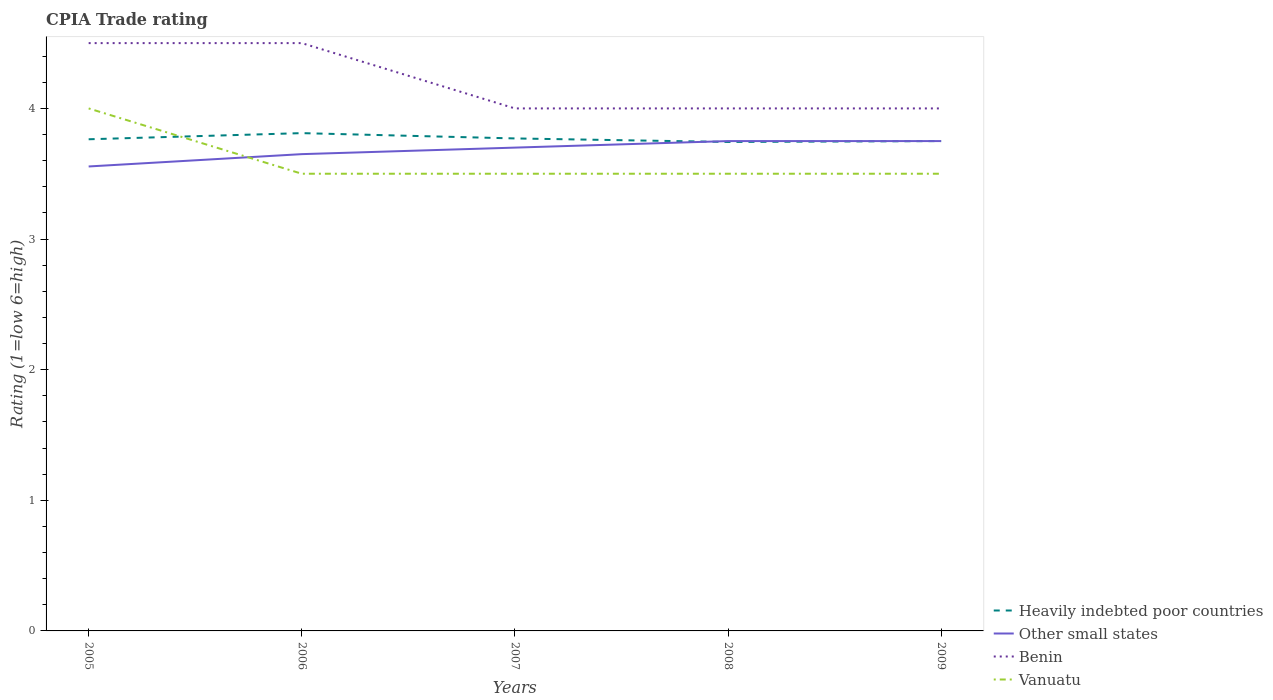Is the number of lines equal to the number of legend labels?
Keep it short and to the point. Yes. Across all years, what is the maximum CPIA rating in Other small states?
Ensure brevity in your answer.  3.56. What is the difference between the highest and the second highest CPIA rating in Heavily indebted poor countries?
Provide a succinct answer. 0.07. How many years are there in the graph?
Ensure brevity in your answer.  5. Does the graph contain any zero values?
Your response must be concise. No. Does the graph contain grids?
Offer a terse response. No. How many legend labels are there?
Offer a terse response. 4. What is the title of the graph?
Your response must be concise. CPIA Trade rating. What is the label or title of the X-axis?
Offer a very short reply. Years. What is the Rating (1=low 6=high) of Heavily indebted poor countries in 2005?
Keep it short and to the point. 3.76. What is the Rating (1=low 6=high) in Other small states in 2005?
Keep it short and to the point. 3.56. What is the Rating (1=low 6=high) of Benin in 2005?
Give a very brief answer. 4.5. What is the Rating (1=low 6=high) in Vanuatu in 2005?
Provide a succinct answer. 4. What is the Rating (1=low 6=high) in Heavily indebted poor countries in 2006?
Give a very brief answer. 3.81. What is the Rating (1=low 6=high) in Other small states in 2006?
Your answer should be very brief. 3.65. What is the Rating (1=low 6=high) in Benin in 2006?
Your response must be concise. 4.5. What is the Rating (1=low 6=high) in Heavily indebted poor countries in 2007?
Provide a short and direct response. 3.77. What is the Rating (1=low 6=high) in Heavily indebted poor countries in 2008?
Give a very brief answer. 3.74. What is the Rating (1=low 6=high) in Other small states in 2008?
Your response must be concise. 3.75. What is the Rating (1=low 6=high) in Benin in 2008?
Make the answer very short. 4. What is the Rating (1=low 6=high) of Vanuatu in 2008?
Ensure brevity in your answer.  3.5. What is the Rating (1=low 6=high) in Heavily indebted poor countries in 2009?
Keep it short and to the point. 3.75. What is the Rating (1=low 6=high) of Other small states in 2009?
Your answer should be compact. 3.75. What is the Rating (1=low 6=high) of Vanuatu in 2009?
Give a very brief answer. 3.5. Across all years, what is the maximum Rating (1=low 6=high) of Heavily indebted poor countries?
Offer a terse response. 3.81. Across all years, what is the maximum Rating (1=low 6=high) in Other small states?
Give a very brief answer. 3.75. Across all years, what is the maximum Rating (1=low 6=high) of Benin?
Provide a succinct answer. 4.5. Across all years, what is the maximum Rating (1=low 6=high) in Vanuatu?
Offer a very short reply. 4. Across all years, what is the minimum Rating (1=low 6=high) of Heavily indebted poor countries?
Ensure brevity in your answer.  3.74. Across all years, what is the minimum Rating (1=low 6=high) of Other small states?
Your answer should be compact. 3.56. Across all years, what is the minimum Rating (1=low 6=high) in Vanuatu?
Make the answer very short. 3.5. What is the total Rating (1=low 6=high) of Heavily indebted poor countries in the graph?
Give a very brief answer. 18.84. What is the total Rating (1=low 6=high) of Other small states in the graph?
Make the answer very short. 18.41. What is the total Rating (1=low 6=high) in Vanuatu in the graph?
Your answer should be very brief. 18. What is the difference between the Rating (1=low 6=high) of Heavily indebted poor countries in 2005 and that in 2006?
Give a very brief answer. -0.05. What is the difference between the Rating (1=low 6=high) in Other small states in 2005 and that in 2006?
Your answer should be very brief. -0.09. What is the difference between the Rating (1=low 6=high) of Vanuatu in 2005 and that in 2006?
Ensure brevity in your answer.  0.5. What is the difference between the Rating (1=low 6=high) of Heavily indebted poor countries in 2005 and that in 2007?
Give a very brief answer. -0.01. What is the difference between the Rating (1=low 6=high) of Other small states in 2005 and that in 2007?
Provide a short and direct response. -0.14. What is the difference between the Rating (1=low 6=high) in Benin in 2005 and that in 2007?
Provide a short and direct response. 0.5. What is the difference between the Rating (1=low 6=high) of Heavily indebted poor countries in 2005 and that in 2008?
Keep it short and to the point. 0.02. What is the difference between the Rating (1=low 6=high) of Other small states in 2005 and that in 2008?
Give a very brief answer. -0.19. What is the difference between the Rating (1=low 6=high) in Heavily indebted poor countries in 2005 and that in 2009?
Your answer should be very brief. 0.01. What is the difference between the Rating (1=low 6=high) in Other small states in 2005 and that in 2009?
Offer a very short reply. -0.19. What is the difference between the Rating (1=low 6=high) of Vanuatu in 2005 and that in 2009?
Your response must be concise. 0.5. What is the difference between the Rating (1=low 6=high) in Heavily indebted poor countries in 2006 and that in 2007?
Give a very brief answer. 0.04. What is the difference between the Rating (1=low 6=high) in Other small states in 2006 and that in 2007?
Give a very brief answer. -0.05. What is the difference between the Rating (1=low 6=high) in Heavily indebted poor countries in 2006 and that in 2008?
Ensure brevity in your answer.  0.07. What is the difference between the Rating (1=low 6=high) of Heavily indebted poor countries in 2006 and that in 2009?
Offer a very short reply. 0.06. What is the difference between the Rating (1=low 6=high) of Benin in 2006 and that in 2009?
Keep it short and to the point. 0.5. What is the difference between the Rating (1=low 6=high) of Vanuatu in 2006 and that in 2009?
Provide a succinct answer. 0. What is the difference between the Rating (1=low 6=high) in Heavily indebted poor countries in 2007 and that in 2008?
Provide a succinct answer. 0.03. What is the difference between the Rating (1=low 6=high) in Other small states in 2007 and that in 2008?
Your answer should be very brief. -0.05. What is the difference between the Rating (1=low 6=high) of Benin in 2007 and that in 2008?
Give a very brief answer. 0. What is the difference between the Rating (1=low 6=high) of Heavily indebted poor countries in 2007 and that in 2009?
Offer a terse response. 0.02. What is the difference between the Rating (1=low 6=high) in Other small states in 2007 and that in 2009?
Provide a succinct answer. -0.05. What is the difference between the Rating (1=low 6=high) in Heavily indebted poor countries in 2008 and that in 2009?
Provide a succinct answer. -0.01. What is the difference between the Rating (1=low 6=high) of Benin in 2008 and that in 2009?
Ensure brevity in your answer.  0. What is the difference between the Rating (1=low 6=high) of Heavily indebted poor countries in 2005 and the Rating (1=low 6=high) of Other small states in 2006?
Give a very brief answer. 0.11. What is the difference between the Rating (1=low 6=high) in Heavily indebted poor countries in 2005 and the Rating (1=low 6=high) in Benin in 2006?
Your response must be concise. -0.74. What is the difference between the Rating (1=low 6=high) of Heavily indebted poor countries in 2005 and the Rating (1=low 6=high) of Vanuatu in 2006?
Your answer should be very brief. 0.26. What is the difference between the Rating (1=low 6=high) in Other small states in 2005 and the Rating (1=low 6=high) in Benin in 2006?
Make the answer very short. -0.94. What is the difference between the Rating (1=low 6=high) of Other small states in 2005 and the Rating (1=low 6=high) of Vanuatu in 2006?
Provide a short and direct response. 0.06. What is the difference between the Rating (1=low 6=high) in Benin in 2005 and the Rating (1=low 6=high) in Vanuatu in 2006?
Make the answer very short. 1. What is the difference between the Rating (1=low 6=high) in Heavily indebted poor countries in 2005 and the Rating (1=low 6=high) in Other small states in 2007?
Your response must be concise. 0.06. What is the difference between the Rating (1=low 6=high) in Heavily indebted poor countries in 2005 and the Rating (1=low 6=high) in Benin in 2007?
Keep it short and to the point. -0.24. What is the difference between the Rating (1=low 6=high) in Heavily indebted poor countries in 2005 and the Rating (1=low 6=high) in Vanuatu in 2007?
Give a very brief answer. 0.26. What is the difference between the Rating (1=low 6=high) in Other small states in 2005 and the Rating (1=low 6=high) in Benin in 2007?
Ensure brevity in your answer.  -0.44. What is the difference between the Rating (1=low 6=high) of Other small states in 2005 and the Rating (1=low 6=high) of Vanuatu in 2007?
Give a very brief answer. 0.06. What is the difference between the Rating (1=low 6=high) in Benin in 2005 and the Rating (1=low 6=high) in Vanuatu in 2007?
Offer a terse response. 1. What is the difference between the Rating (1=low 6=high) of Heavily indebted poor countries in 2005 and the Rating (1=low 6=high) of Other small states in 2008?
Offer a terse response. 0.01. What is the difference between the Rating (1=low 6=high) in Heavily indebted poor countries in 2005 and the Rating (1=low 6=high) in Benin in 2008?
Provide a succinct answer. -0.24. What is the difference between the Rating (1=low 6=high) of Heavily indebted poor countries in 2005 and the Rating (1=low 6=high) of Vanuatu in 2008?
Offer a very short reply. 0.26. What is the difference between the Rating (1=low 6=high) of Other small states in 2005 and the Rating (1=low 6=high) of Benin in 2008?
Offer a terse response. -0.44. What is the difference between the Rating (1=low 6=high) of Other small states in 2005 and the Rating (1=low 6=high) of Vanuatu in 2008?
Offer a very short reply. 0.06. What is the difference between the Rating (1=low 6=high) in Benin in 2005 and the Rating (1=low 6=high) in Vanuatu in 2008?
Your answer should be compact. 1. What is the difference between the Rating (1=low 6=high) of Heavily indebted poor countries in 2005 and the Rating (1=low 6=high) of Other small states in 2009?
Keep it short and to the point. 0.01. What is the difference between the Rating (1=low 6=high) of Heavily indebted poor countries in 2005 and the Rating (1=low 6=high) of Benin in 2009?
Provide a succinct answer. -0.24. What is the difference between the Rating (1=low 6=high) of Heavily indebted poor countries in 2005 and the Rating (1=low 6=high) of Vanuatu in 2009?
Provide a succinct answer. 0.26. What is the difference between the Rating (1=low 6=high) in Other small states in 2005 and the Rating (1=low 6=high) in Benin in 2009?
Offer a terse response. -0.44. What is the difference between the Rating (1=low 6=high) of Other small states in 2005 and the Rating (1=low 6=high) of Vanuatu in 2009?
Your answer should be very brief. 0.06. What is the difference between the Rating (1=low 6=high) in Benin in 2005 and the Rating (1=low 6=high) in Vanuatu in 2009?
Ensure brevity in your answer.  1. What is the difference between the Rating (1=low 6=high) in Heavily indebted poor countries in 2006 and the Rating (1=low 6=high) in Other small states in 2007?
Keep it short and to the point. 0.11. What is the difference between the Rating (1=low 6=high) in Heavily indebted poor countries in 2006 and the Rating (1=low 6=high) in Benin in 2007?
Your answer should be compact. -0.19. What is the difference between the Rating (1=low 6=high) of Heavily indebted poor countries in 2006 and the Rating (1=low 6=high) of Vanuatu in 2007?
Your answer should be very brief. 0.31. What is the difference between the Rating (1=low 6=high) in Other small states in 2006 and the Rating (1=low 6=high) in Benin in 2007?
Your response must be concise. -0.35. What is the difference between the Rating (1=low 6=high) of Heavily indebted poor countries in 2006 and the Rating (1=low 6=high) of Other small states in 2008?
Ensure brevity in your answer.  0.06. What is the difference between the Rating (1=low 6=high) in Heavily indebted poor countries in 2006 and the Rating (1=low 6=high) in Benin in 2008?
Keep it short and to the point. -0.19. What is the difference between the Rating (1=low 6=high) in Heavily indebted poor countries in 2006 and the Rating (1=low 6=high) in Vanuatu in 2008?
Offer a terse response. 0.31. What is the difference between the Rating (1=low 6=high) in Other small states in 2006 and the Rating (1=low 6=high) in Benin in 2008?
Make the answer very short. -0.35. What is the difference between the Rating (1=low 6=high) of Benin in 2006 and the Rating (1=low 6=high) of Vanuatu in 2008?
Offer a terse response. 1. What is the difference between the Rating (1=low 6=high) of Heavily indebted poor countries in 2006 and the Rating (1=low 6=high) of Other small states in 2009?
Make the answer very short. 0.06. What is the difference between the Rating (1=low 6=high) of Heavily indebted poor countries in 2006 and the Rating (1=low 6=high) of Benin in 2009?
Ensure brevity in your answer.  -0.19. What is the difference between the Rating (1=low 6=high) of Heavily indebted poor countries in 2006 and the Rating (1=low 6=high) of Vanuatu in 2009?
Your answer should be very brief. 0.31. What is the difference between the Rating (1=low 6=high) in Other small states in 2006 and the Rating (1=low 6=high) in Benin in 2009?
Your response must be concise. -0.35. What is the difference between the Rating (1=low 6=high) in Benin in 2006 and the Rating (1=low 6=high) in Vanuatu in 2009?
Make the answer very short. 1. What is the difference between the Rating (1=low 6=high) of Heavily indebted poor countries in 2007 and the Rating (1=low 6=high) of Other small states in 2008?
Offer a terse response. 0.02. What is the difference between the Rating (1=low 6=high) of Heavily indebted poor countries in 2007 and the Rating (1=low 6=high) of Benin in 2008?
Provide a short and direct response. -0.23. What is the difference between the Rating (1=low 6=high) of Heavily indebted poor countries in 2007 and the Rating (1=low 6=high) of Vanuatu in 2008?
Your answer should be very brief. 0.27. What is the difference between the Rating (1=low 6=high) of Other small states in 2007 and the Rating (1=low 6=high) of Vanuatu in 2008?
Make the answer very short. 0.2. What is the difference between the Rating (1=low 6=high) of Benin in 2007 and the Rating (1=low 6=high) of Vanuatu in 2008?
Offer a terse response. 0.5. What is the difference between the Rating (1=low 6=high) of Heavily indebted poor countries in 2007 and the Rating (1=low 6=high) of Other small states in 2009?
Your response must be concise. 0.02. What is the difference between the Rating (1=low 6=high) in Heavily indebted poor countries in 2007 and the Rating (1=low 6=high) in Benin in 2009?
Keep it short and to the point. -0.23. What is the difference between the Rating (1=low 6=high) of Heavily indebted poor countries in 2007 and the Rating (1=low 6=high) of Vanuatu in 2009?
Provide a short and direct response. 0.27. What is the difference between the Rating (1=low 6=high) of Other small states in 2007 and the Rating (1=low 6=high) of Vanuatu in 2009?
Offer a terse response. 0.2. What is the difference between the Rating (1=low 6=high) of Benin in 2007 and the Rating (1=low 6=high) of Vanuatu in 2009?
Offer a terse response. 0.5. What is the difference between the Rating (1=low 6=high) of Heavily indebted poor countries in 2008 and the Rating (1=low 6=high) of Other small states in 2009?
Give a very brief answer. -0.01. What is the difference between the Rating (1=low 6=high) in Heavily indebted poor countries in 2008 and the Rating (1=low 6=high) in Benin in 2009?
Your answer should be very brief. -0.26. What is the difference between the Rating (1=low 6=high) in Heavily indebted poor countries in 2008 and the Rating (1=low 6=high) in Vanuatu in 2009?
Your response must be concise. 0.24. What is the difference between the Rating (1=low 6=high) of Other small states in 2008 and the Rating (1=low 6=high) of Vanuatu in 2009?
Give a very brief answer. 0.25. What is the average Rating (1=low 6=high) of Heavily indebted poor countries per year?
Provide a short and direct response. 3.77. What is the average Rating (1=low 6=high) in Other small states per year?
Offer a terse response. 3.68. In the year 2005, what is the difference between the Rating (1=low 6=high) in Heavily indebted poor countries and Rating (1=low 6=high) in Other small states?
Offer a terse response. 0.21. In the year 2005, what is the difference between the Rating (1=low 6=high) in Heavily indebted poor countries and Rating (1=low 6=high) in Benin?
Make the answer very short. -0.74. In the year 2005, what is the difference between the Rating (1=low 6=high) in Heavily indebted poor countries and Rating (1=low 6=high) in Vanuatu?
Your answer should be very brief. -0.24. In the year 2005, what is the difference between the Rating (1=low 6=high) in Other small states and Rating (1=low 6=high) in Benin?
Keep it short and to the point. -0.94. In the year 2005, what is the difference between the Rating (1=low 6=high) in Other small states and Rating (1=low 6=high) in Vanuatu?
Your answer should be very brief. -0.44. In the year 2006, what is the difference between the Rating (1=low 6=high) of Heavily indebted poor countries and Rating (1=low 6=high) of Other small states?
Make the answer very short. 0.16. In the year 2006, what is the difference between the Rating (1=low 6=high) of Heavily indebted poor countries and Rating (1=low 6=high) of Benin?
Your response must be concise. -0.69. In the year 2006, what is the difference between the Rating (1=low 6=high) in Heavily indebted poor countries and Rating (1=low 6=high) in Vanuatu?
Your answer should be compact. 0.31. In the year 2006, what is the difference between the Rating (1=low 6=high) of Other small states and Rating (1=low 6=high) of Benin?
Offer a very short reply. -0.85. In the year 2006, what is the difference between the Rating (1=low 6=high) in Other small states and Rating (1=low 6=high) in Vanuatu?
Offer a terse response. 0.15. In the year 2006, what is the difference between the Rating (1=low 6=high) in Benin and Rating (1=low 6=high) in Vanuatu?
Offer a terse response. 1. In the year 2007, what is the difference between the Rating (1=low 6=high) of Heavily indebted poor countries and Rating (1=low 6=high) of Other small states?
Offer a terse response. 0.07. In the year 2007, what is the difference between the Rating (1=low 6=high) in Heavily indebted poor countries and Rating (1=low 6=high) in Benin?
Give a very brief answer. -0.23. In the year 2007, what is the difference between the Rating (1=low 6=high) in Heavily indebted poor countries and Rating (1=low 6=high) in Vanuatu?
Provide a short and direct response. 0.27. In the year 2007, what is the difference between the Rating (1=low 6=high) of Benin and Rating (1=low 6=high) of Vanuatu?
Give a very brief answer. 0.5. In the year 2008, what is the difference between the Rating (1=low 6=high) in Heavily indebted poor countries and Rating (1=low 6=high) in Other small states?
Give a very brief answer. -0.01. In the year 2008, what is the difference between the Rating (1=low 6=high) in Heavily indebted poor countries and Rating (1=low 6=high) in Benin?
Keep it short and to the point. -0.26. In the year 2008, what is the difference between the Rating (1=low 6=high) of Heavily indebted poor countries and Rating (1=low 6=high) of Vanuatu?
Ensure brevity in your answer.  0.24. In the year 2008, what is the difference between the Rating (1=low 6=high) of Other small states and Rating (1=low 6=high) of Vanuatu?
Give a very brief answer. 0.25. In the year 2009, what is the difference between the Rating (1=low 6=high) of Heavily indebted poor countries and Rating (1=low 6=high) of Vanuatu?
Your response must be concise. 0.25. In the year 2009, what is the difference between the Rating (1=low 6=high) of Other small states and Rating (1=low 6=high) of Benin?
Your answer should be very brief. -0.25. In the year 2009, what is the difference between the Rating (1=low 6=high) in Other small states and Rating (1=low 6=high) in Vanuatu?
Your response must be concise. 0.25. What is the ratio of the Rating (1=low 6=high) in Heavily indebted poor countries in 2005 to that in 2006?
Offer a terse response. 0.99. What is the ratio of the Rating (1=low 6=high) in Other small states in 2005 to that in 2006?
Make the answer very short. 0.97. What is the ratio of the Rating (1=low 6=high) of Benin in 2005 to that in 2006?
Ensure brevity in your answer.  1. What is the ratio of the Rating (1=low 6=high) of Heavily indebted poor countries in 2005 to that in 2007?
Your answer should be very brief. 1. What is the ratio of the Rating (1=low 6=high) of Vanuatu in 2005 to that in 2007?
Provide a short and direct response. 1.14. What is the ratio of the Rating (1=low 6=high) in Heavily indebted poor countries in 2005 to that in 2008?
Offer a terse response. 1.01. What is the ratio of the Rating (1=low 6=high) in Other small states in 2005 to that in 2008?
Make the answer very short. 0.95. What is the ratio of the Rating (1=low 6=high) in Heavily indebted poor countries in 2005 to that in 2009?
Give a very brief answer. 1. What is the ratio of the Rating (1=low 6=high) of Other small states in 2005 to that in 2009?
Offer a very short reply. 0.95. What is the ratio of the Rating (1=low 6=high) in Vanuatu in 2005 to that in 2009?
Make the answer very short. 1.14. What is the ratio of the Rating (1=low 6=high) of Heavily indebted poor countries in 2006 to that in 2007?
Keep it short and to the point. 1.01. What is the ratio of the Rating (1=low 6=high) of Other small states in 2006 to that in 2007?
Provide a succinct answer. 0.99. What is the ratio of the Rating (1=low 6=high) in Benin in 2006 to that in 2007?
Keep it short and to the point. 1.12. What is the ratio of the Rating (1=low 6=high) in Heavily indebted poor countries in 2006 to that in 2008?
Make the answer very short. 1.02. What is the ratio of the Rating (1=low 6=high) of Other small states in 2006 to that in 2008?
Ensure brevity in your answer.  0.97. What is the ratio of the Rating (1=low 6=high) in Heavily indebted poor countries in 2006 to that in 2009?
Your response must be concise. 1.02. What is the ratio of the Rating (1=low 6=high) of Other small states in 2006 to that in 2009?
Give a very brief answer. 0.97. What is the ratio of the Rating (1=low 6=high) in Benin in 2006 to that in 2009?
Keep it short and to the point. 1.12. What is the ratio of the Rating (1=low 6=high) in Other small states in 2007 to that in 2008?
Your answer should be compact. 0.99. What is the ratio of the Rating (1=low 6=high) of Vanuatu in 2007 to that in 2008?
Ensure brevity in your answer.  1. What is the ratio of the Rating (1=low 6=high) of Heavily indebted poor countries in 2007 to that in 2009?
Keep it short and to the point. 1.01. What is the ratio of the Rating (1=low 6=high) of Other small states in 2007 to that in 2009?
Your answer should be compact. 0.99. What is the ratio of the Rating (1=low 6=high) of Vanuatu in 2007 to that in 2009?
Give a very brief answer. 1. What is the ratio of the Rating (1=low 6=high) in Heavily indebted poor countries in 2008 to that in 2009?
Your answer should be compact. 1. What is the ratio of the Rating (1=low 6=high) in Other small states in 2008 to that in 2009?
Provide a short and direct response. 1. What is the ratio of the Rating (1=low 6=high) in Benin in 2008 to that in 2009?
Provide a short and direct response. 1. What is the ratio of the Rating (1=low 6=high) in Vanuatu in 2008 to that in 2009?
Provide a succinct answer. 1. What is the difference between the highest and the second highest Rating (1=low 6=high) in Heavily indebted poor countries?
Give a very brief answer. 0.04. What is the difference between the highest and the second highest Rating (1=low 6=high) in Other small states?
Your response must be concise. 0. What is the difference between the highest and the second highest Rating (1=low 6=high) in Vanuatu?
Your response must be concise. 0.5. What is the difference between the highest and the lowest Rating (1=low 6=high) in Heavily indebted poor countries?
Ensure brevity in your answer.  0.07. What is the difference between the highest and the lowest Rating (1=low 6=high) of Other small states?
Ensure brevity in your answer.  0.19. What is the difference between the highest and the lowest Rating (1=low 6=high) of Vanuatu?
Your response must be concise. 0.5. 